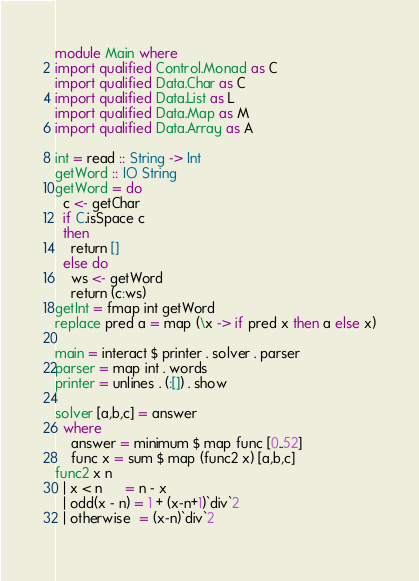Convert code to text. <code><loc_0><loc_0><loc_500><loc_500><_Haskell_>module Main where
import qualified Control.Monad as C
import qualified Data.Char as C
import qualified Data.List as L
import qualified Data.Map as M
import qualified Data.Array as A

int = read :: String -> Int
getWord :: IO String
getWord = do
  c <- getChar
  if C.isSpace c
  then
    return []
  else do
    ws <- getWord
    return (c:ws)
getInt = fmap int getWord
replace pred a = map (\x -> if pred x then a else x)

main = interact $ printer . solver . parser
parser = map int . words
printer = unlines . (:[]) . show

solver [a,b,c] = answer
  where
    answer = minimum $ map func [0..52]
    func x = sum $ map (func2 x) [a,b,c]
func2 x n  
  | x < n      = n - x 
  | odd(x - n) = 1 + (x-n+1)`div`2
  | otherwise  = (x-n)`div`2
  
</code> 